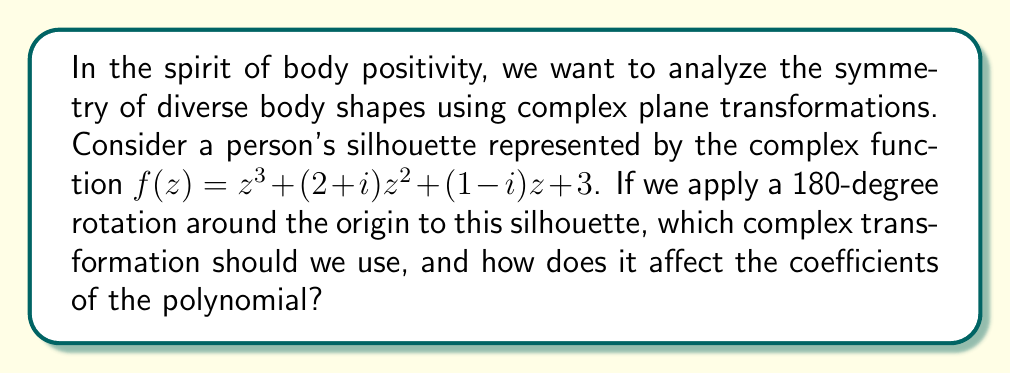Solve this math problem. Let's approach this step-by-step:

1) A 180-degree rotation around the origin in the complex plane is equivalent to multiplying by -1. This transformation can be represented as $z \mapsto -z$.

2) To apply this transformation to our function $f(z)$, we replace every $z$ with $-z$:

   $f(-z) = (-z)^3 + (2+i)(-z)^2 + (1-i)(-z) + 3$

3) Let's simplify each term:
   - $(-z)^3 = -z^3$
   - $(2+i)(-z)^2 = (2+i)z^2$
   - $(1-i)(-z) = -(1-i)z$
   - The constant term remains unchanged

4) After simplification:

   $f(-z) = -z^3 + (2+i)z^2 - (1-i)z + 3$

5) Now, let's compare this with our original function:

   $f(z) = z^3 + (2+i)z^2 + (1-i)z + 3$

6) We can see that:
   - The coefficient of $z^3$ changed from 1 to -1
   - The coefficient of $z^2$ remained $(2+i)$
   - The coefficient of $z$ changed from $(1-i)$ to $-(1-i)$
   - The constant term remained 3

7) In general, for a polynomial $a_nz^n + a_{n-1}z^{n-1} + ... + a_1z + a_0$, a 180-degree rotation will change the signs of the coefficients of odd powers of $z$, while leaving the coefficients of even powers unchanged.
Answer: $z \mapsto -z$; odd-degree coefficients change sign, even-degree remain same 